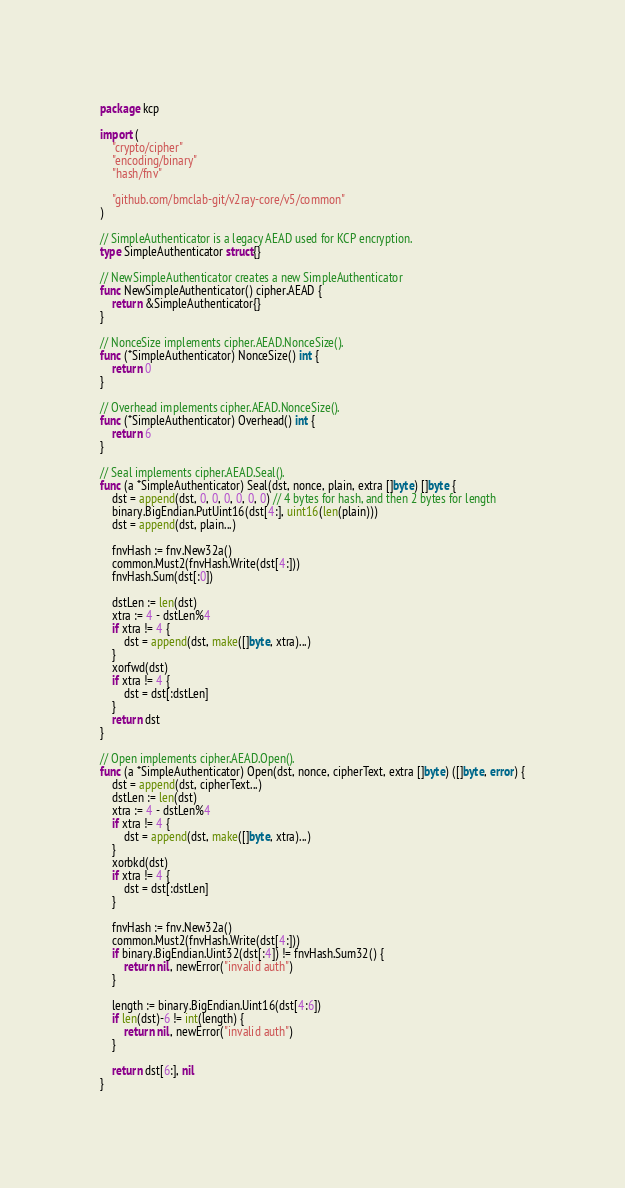Convert code to text. <code><loc_0><loc_0><loc_500><loc_500><_Go_>package kcp

import (
	"crypto/cipher"
	"encoding/binary"
	"hash/fnv"

	"github.com/bmclab-git/v2ray-core/v5/common"
)

// SimpleAuthenticator is a legacy AEAD used for KCP encryption.
type SimpleAuthenticator struct{}

// NewSimpleAuthenticator creates a new SimpleAuthenticator
func NewSimpleAuthenticator() cipher.AEAD {
	return &SimpleAuthenticator{}
}

// NonceSize implements cipher.AEAD.NonceSize().
func (*SimpleAuthenticator) NonceSize() int {
	return 0
}

// Overhead implements cipher.AEAD.NonceSize().
func (*SimpleAuthenticator) Overhead() int {
	return 6
}

// Seal implements cipher.AEAD.Seal().
func (a *SimpleAuthenticator) Seal(dst, nonce, plain, extra []byte) []byte {
	dst = append(dst, 0, 0, 0, 0, 0, 0) // 4 bytes for hash, and then 2 bytes for length
	binary.BigEndian.PutUint16(dst[4:], uint16(len(plain)))
	dst = append(dst, plain...)

	fnvHash := fnv.New32a()
	common.Must2(fnvHash.Write(dst[4:]))
	fnvHash.Sum(dst[:0])

	dstLen := len(dst)
	xtra := 4 - dstLen%4
	if xtra != 4 {
		dst = append(dst, make([]byte, xtra)...)
	}
	xorfwd(dst)
	if xtra != 4 {
		dst = dst[:dstLen]
	}
	return dst
}

// Open implements cipher.AEAD.Open().
func (a *SimpleAuthenticator) Open(dst, nonce, cipherText, extra []byte) ([]byte, error) {
	dst = append(dst, cipherText...)
	dstLen := len(dst)
	xtra := 4 - dstLen%4
	if xtra != 4 {
		dst = append(dst, make([]byte, xtra)...)
	}
	xorbkd(dst)
	if xtra != 4 {
		dst = dst[:dstLen]
	}

	fnvHash := fnv.New32a()
	common.Must2(fnvHash.Write(dst[4:]))
	if binary.BigEndian.Uint32(dst[:4]) != fnvHash.Sum32() {
		return nil, newError("invalid auth")
	}

	length := binary.BigEndian.Uint16(dst[4:6])
	if len(dst)-6 != int(length) {
		return nil, newError("invalid auth")
	}

	return dst[6:], nil
}
</code> 